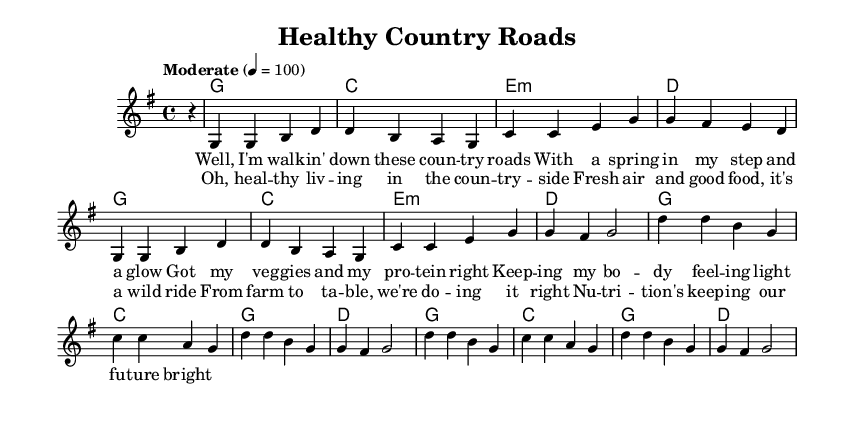what is the key signature of this music? The key signature is G major, which has one sharp (F#). This can be identified from the beginning of the staff where the key signature is notated.
Answer: G major what is the time signature of this music? The time signature is 4/4, which indicates there are four beats in each measure and the quarter note gets one beat. This is clearly shown at the beginning of the score.
Answer: 4/4 what is the tempo marking for this music? The tempo marking is "Moderate" at a speed of quarter note equals 100 beats per minute. This is indicated in the score near the beginning.
Answer: Moderate 4 = 100 how many measures are in the verse? The verse consists of 4 measures as each line of lyrics corresponds to 4 musical beats, and there are four lines in the verse provided which fit within those measures.
Answer: 4 which chord is played for the first measure? The chord played for the first measure is G major. This can be seen by looking at the harmonies section above the measure.
Answer: G what theme is reflected in the lyrics of this song? The theme reflected in the lyrics is healthy living and nutrition. This is evident from the content of the lyrics which mention ‘veggies’, ‘protein’, and ‘nutrition’.
Answer: Healthy living and nutrition how does the chorus relate to the overall message of the song? The chorus emphasizes the importance of fresh food and good nutrition in a rural lifestyle, connecting it to the overall message of healthy living that is present throughout the song. This relationship is clear from the repeated focus on healthy choices in the chorus lyrics.
Answer: Importance of fresh food and good nutrition 